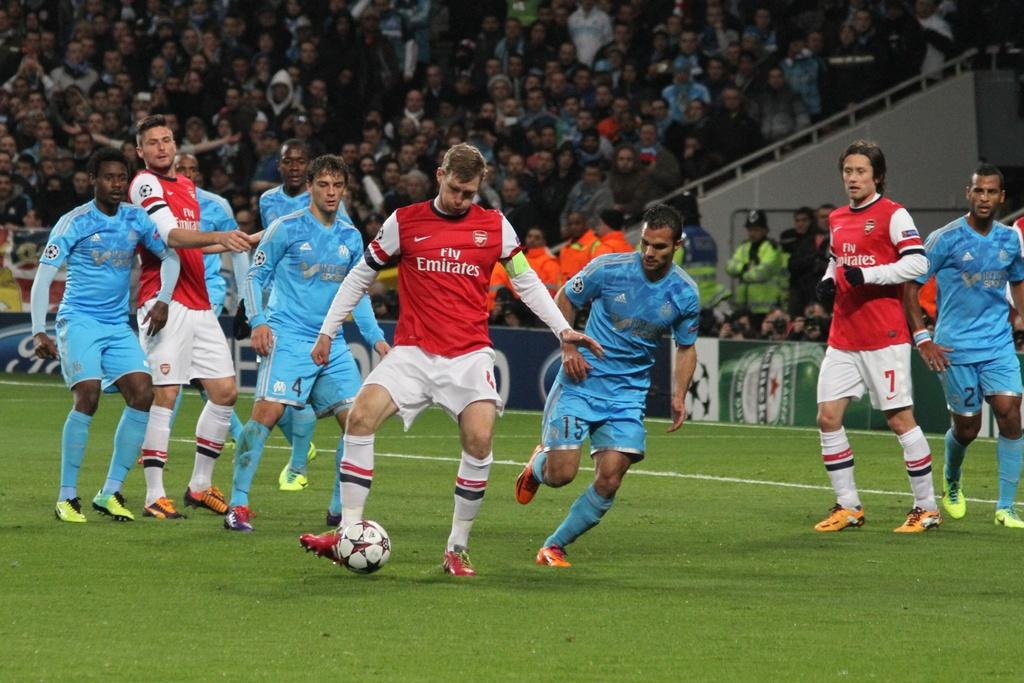Provide a one-sentence caption for the provided image. A soccer game is being played with the Emirates. 